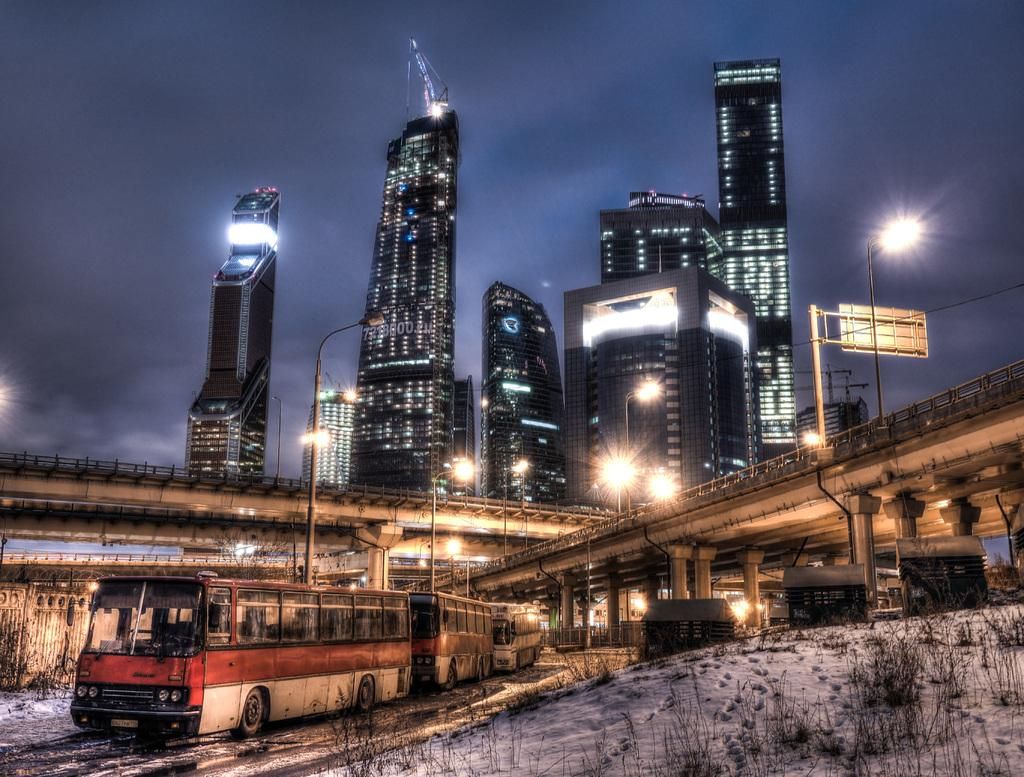What can be seen in the image? There are vehicles in the image. What is visible in the background of the image? There are bridges, light poles, and buildings in the background of the image. What is the color of the sky in the image? The sky is blue in color. What type of silk is being used to decorate the mice in the image? There are no mice or silk present in the image. 